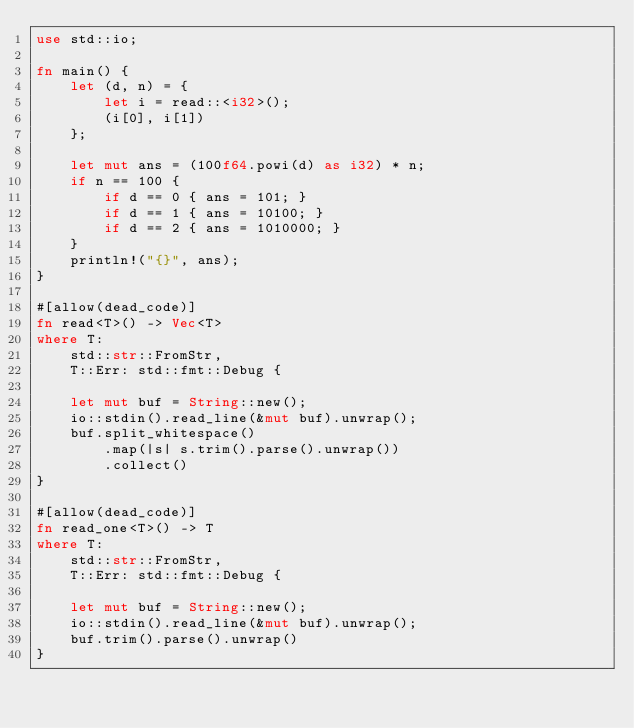Convert code to text. <code><loc_0><loc_0><loc_500><loc_500><_Rust_>use std::io;

fn main() {
    let (d, n) = {
        let i = read::<i32>();
        (i[0], i[1])
    };

    let mut ans = (100f64.powi(d) as i32) * n;
    if n == 100 {
        if d == 0 { ans = 101; }
        if d == 1 { ans = 10100; }
        if d == 2 { ans = 1010000; }
    }
    println!("{}", ans);
}

#[allow(dead_code)]
fn read<T>() -> Vec<T>
where T:
    std::str::FromStr,
    T::Err: std::fmt::Debug {

    let mut buf = String::new();
    io::stdin().read_line(&mut buf).unwrap();
    buf.split_whitespace()
        .map(|s| s.trim().parse().unwrap())
        .collect()
}

#[allow(dead_code)]
fn read_one<T>() -> T
where T:
    std::str::FromStr,
    T::Err: std::fmt::Debug {

    let mut buf = String::new();
    io::stdin().read_line(&mut buf).unwrap();
    buf.trim().parse().unwrap()
}</code> 